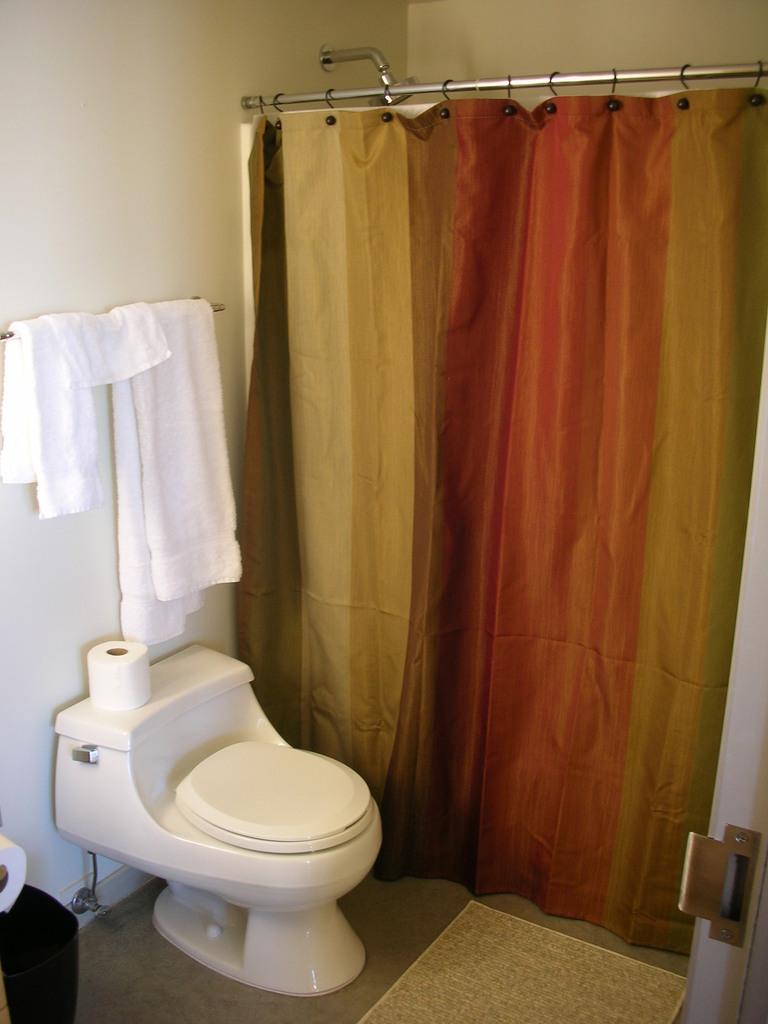In one or two sentences, can you explain what this image depicts? This picture shows the inner view of a room, one shower, one towel rod attached to the wall, one object attached to the wall, few objects on the bottom left side of the image, one curtain attached to the rod, three towels on the towel rod, one mat on the floor, one door, one paper roll on the western toilet. 